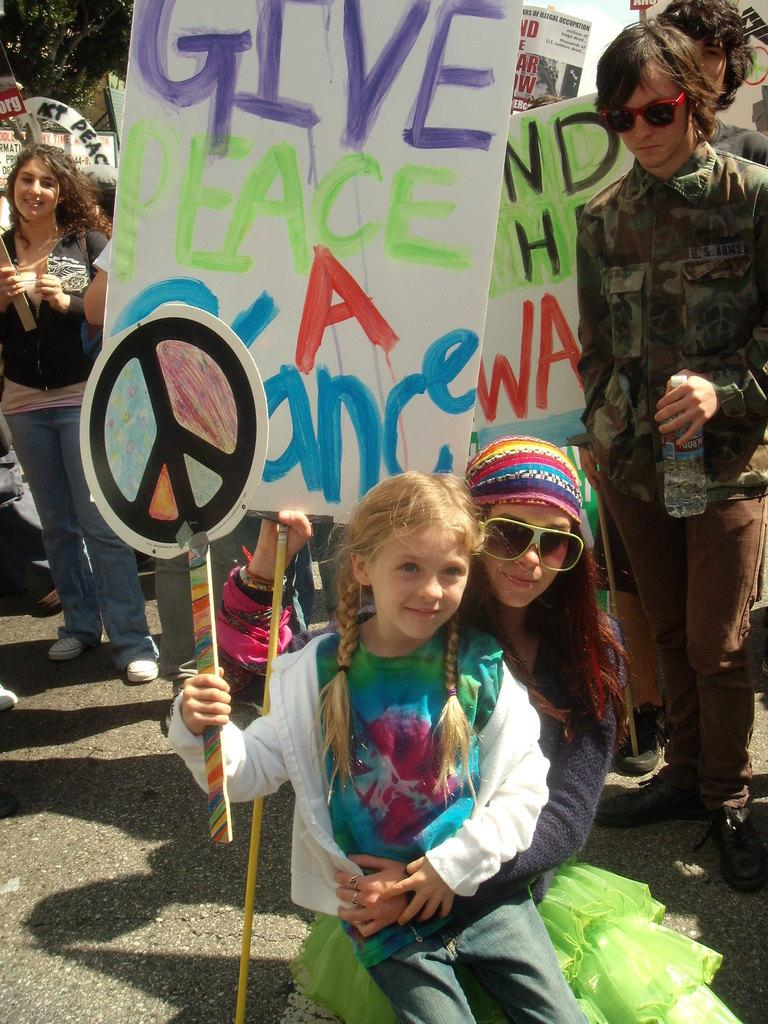How many people are sitting at the front of the image? There are two persons sitting at the front of the image. What are the persons at the front holding? The persons at the front are holding banners. How many people are standing at the back of the image? There are people standing at the back of the image. What are the people at the back holding? The people at the back are also holding banners. What can be seen in the background of the image? There are trees visible in the background of the image. Can you give me the advice that the key to quicksand is hidden in the image? There is no key or reference to quicksand present in the image. 